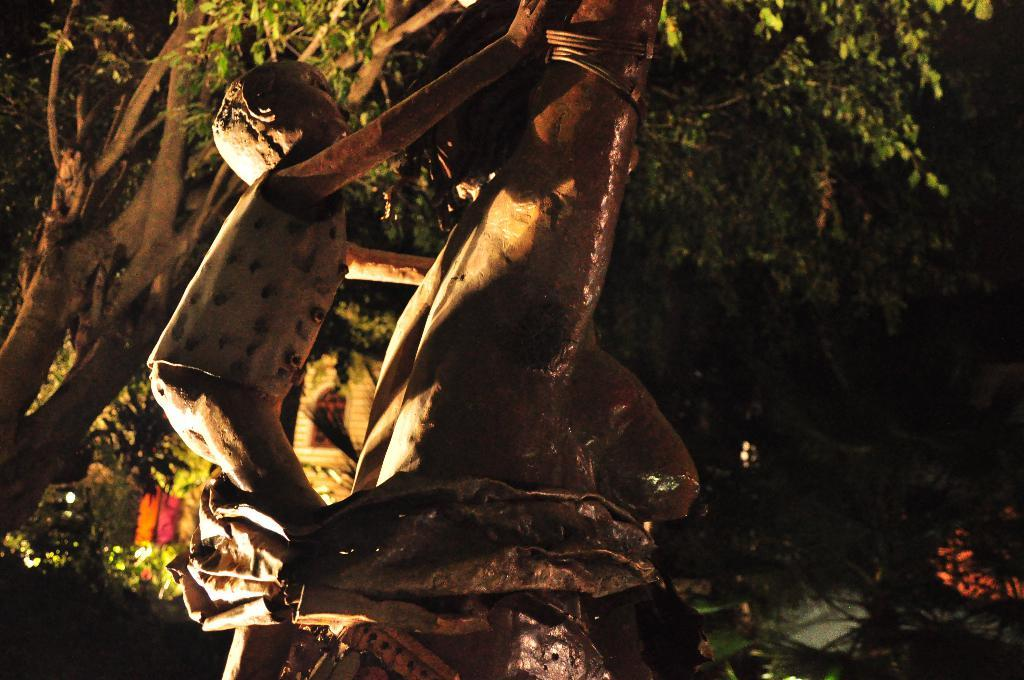What can be seen in the image? There are statues in the image, including a statue of a boy. Can you describe the statue of the boy? The statue of the boy is brown in color. What is visible in the background of the image? There are trees in the background of the image. How would you describe the lighting on the right side of the image? The right side of the image appears to be dark. Are there any sticks with bells attached to them in the image? There are no sticks or bells present in the image. Can you see a knot tied on the statue of the boy? There is no knot visible on the statue of the boy in the image. 